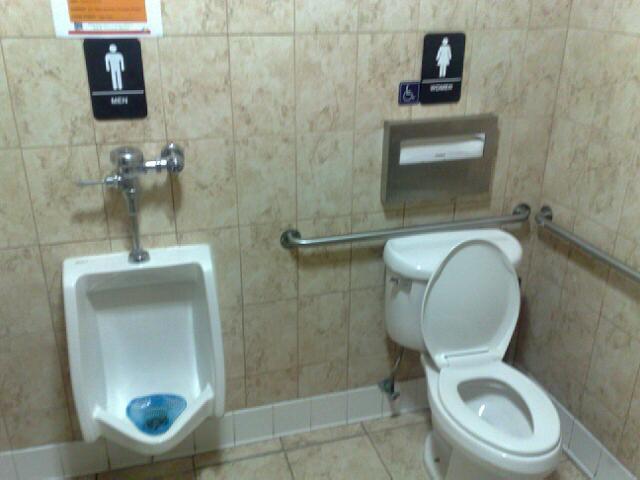Is this a private bathroom?
Be succinct. No. Why is the water blue?
Quick response, please. Urinal cleaner. Are there any handrails in the bathroom?
Quick response, please. Yes. 